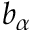<formula> <loc_0><loc_0><loc_500><loc_500>b _ { \alpha }</formula> 